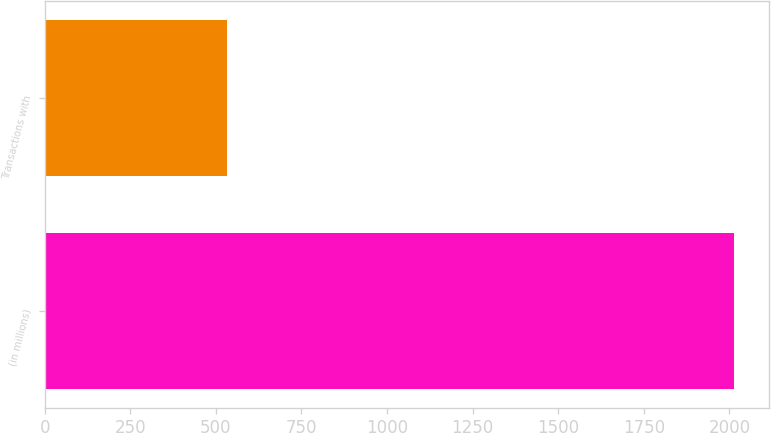Convert chart to OTSL. <chart><loc_0><loc_0><loc_500><loc_500><bar_chart><fcel>(in millions)<fcel>Transactions with<nl><fcel>2014<fcel>532.8<nl></chart> 